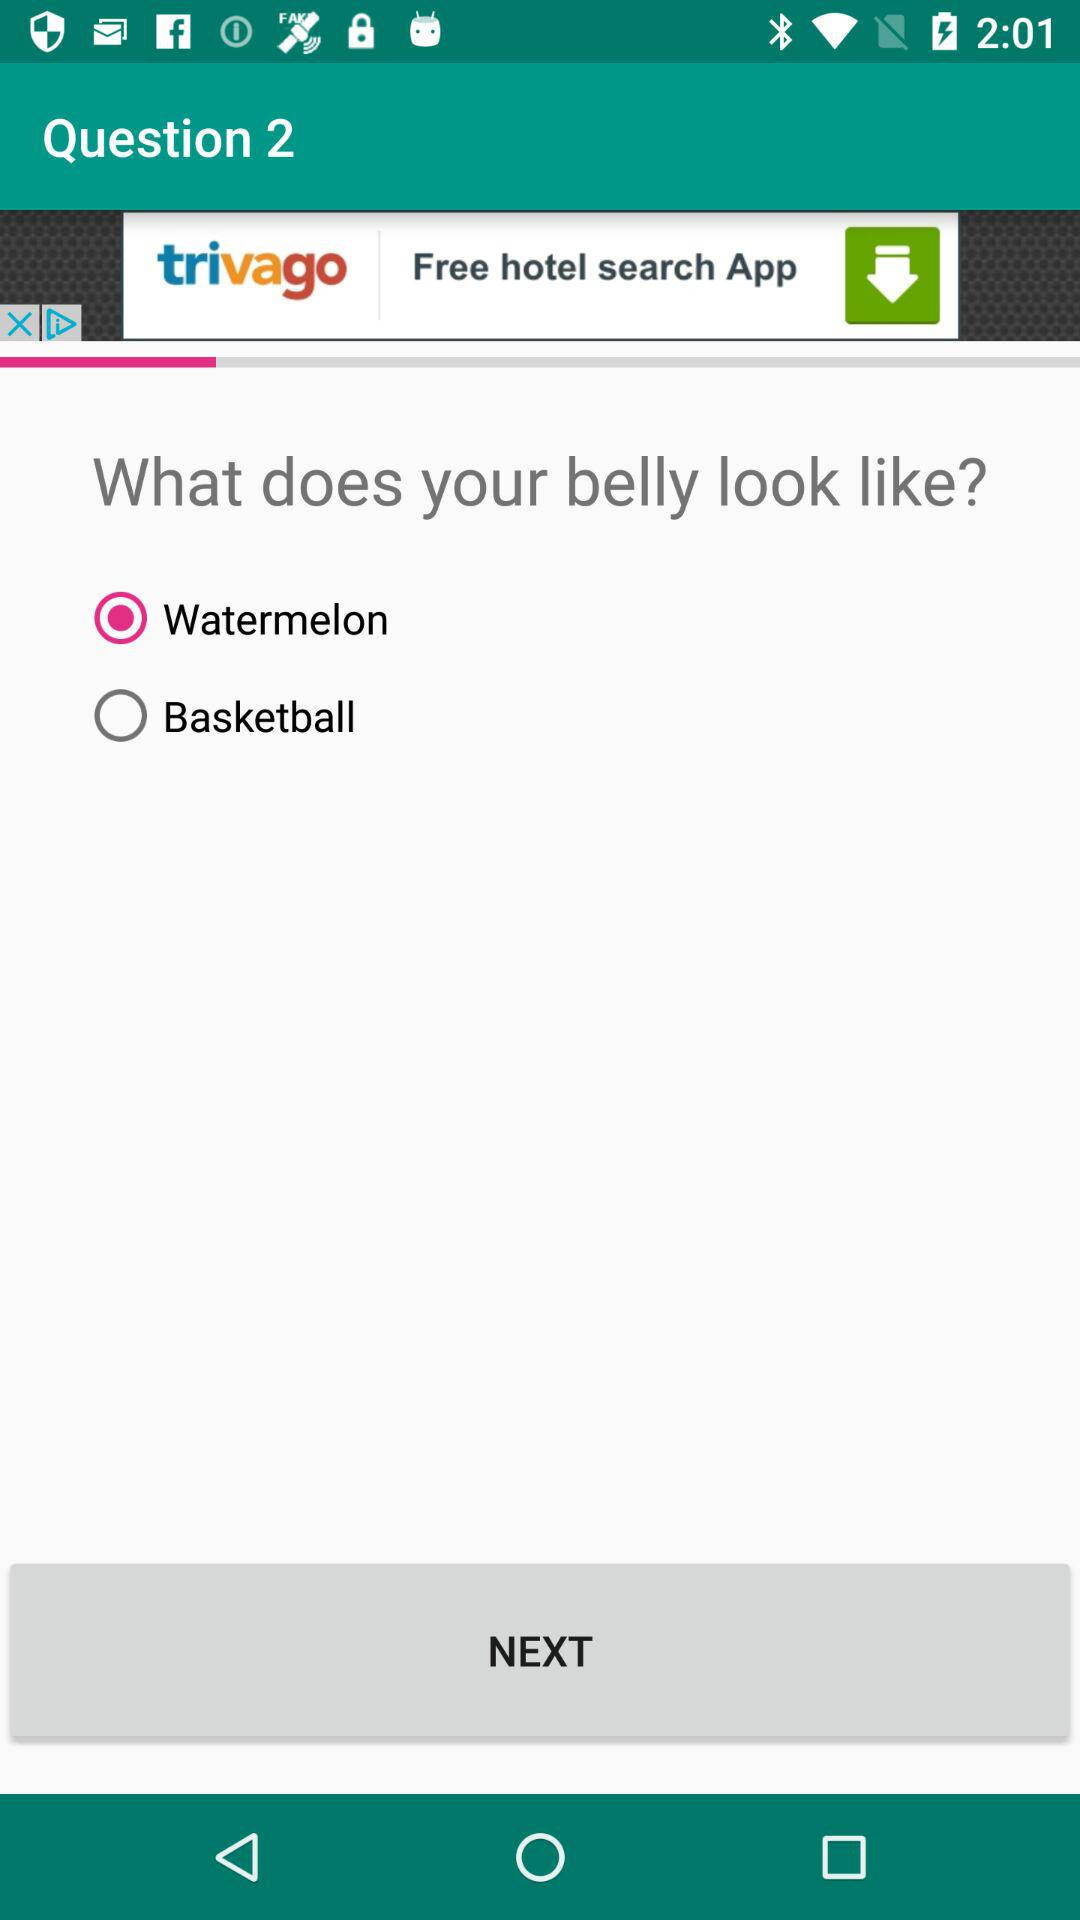How many options are there to describe my belly?
Answer the question using a single word or phrase. 2 